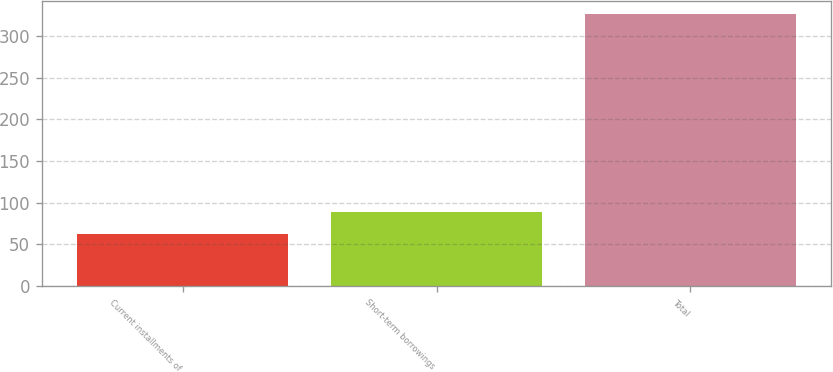Convert chart to OTSL. <chart><loc_0><loc_0><loc_500><loc_500><bar_chart><fcel>Current installments of<fcel>Short-term borrowings<fcel>Total<nl><fcel>63<fcel>89.3<fcel>326<nl></chart> 